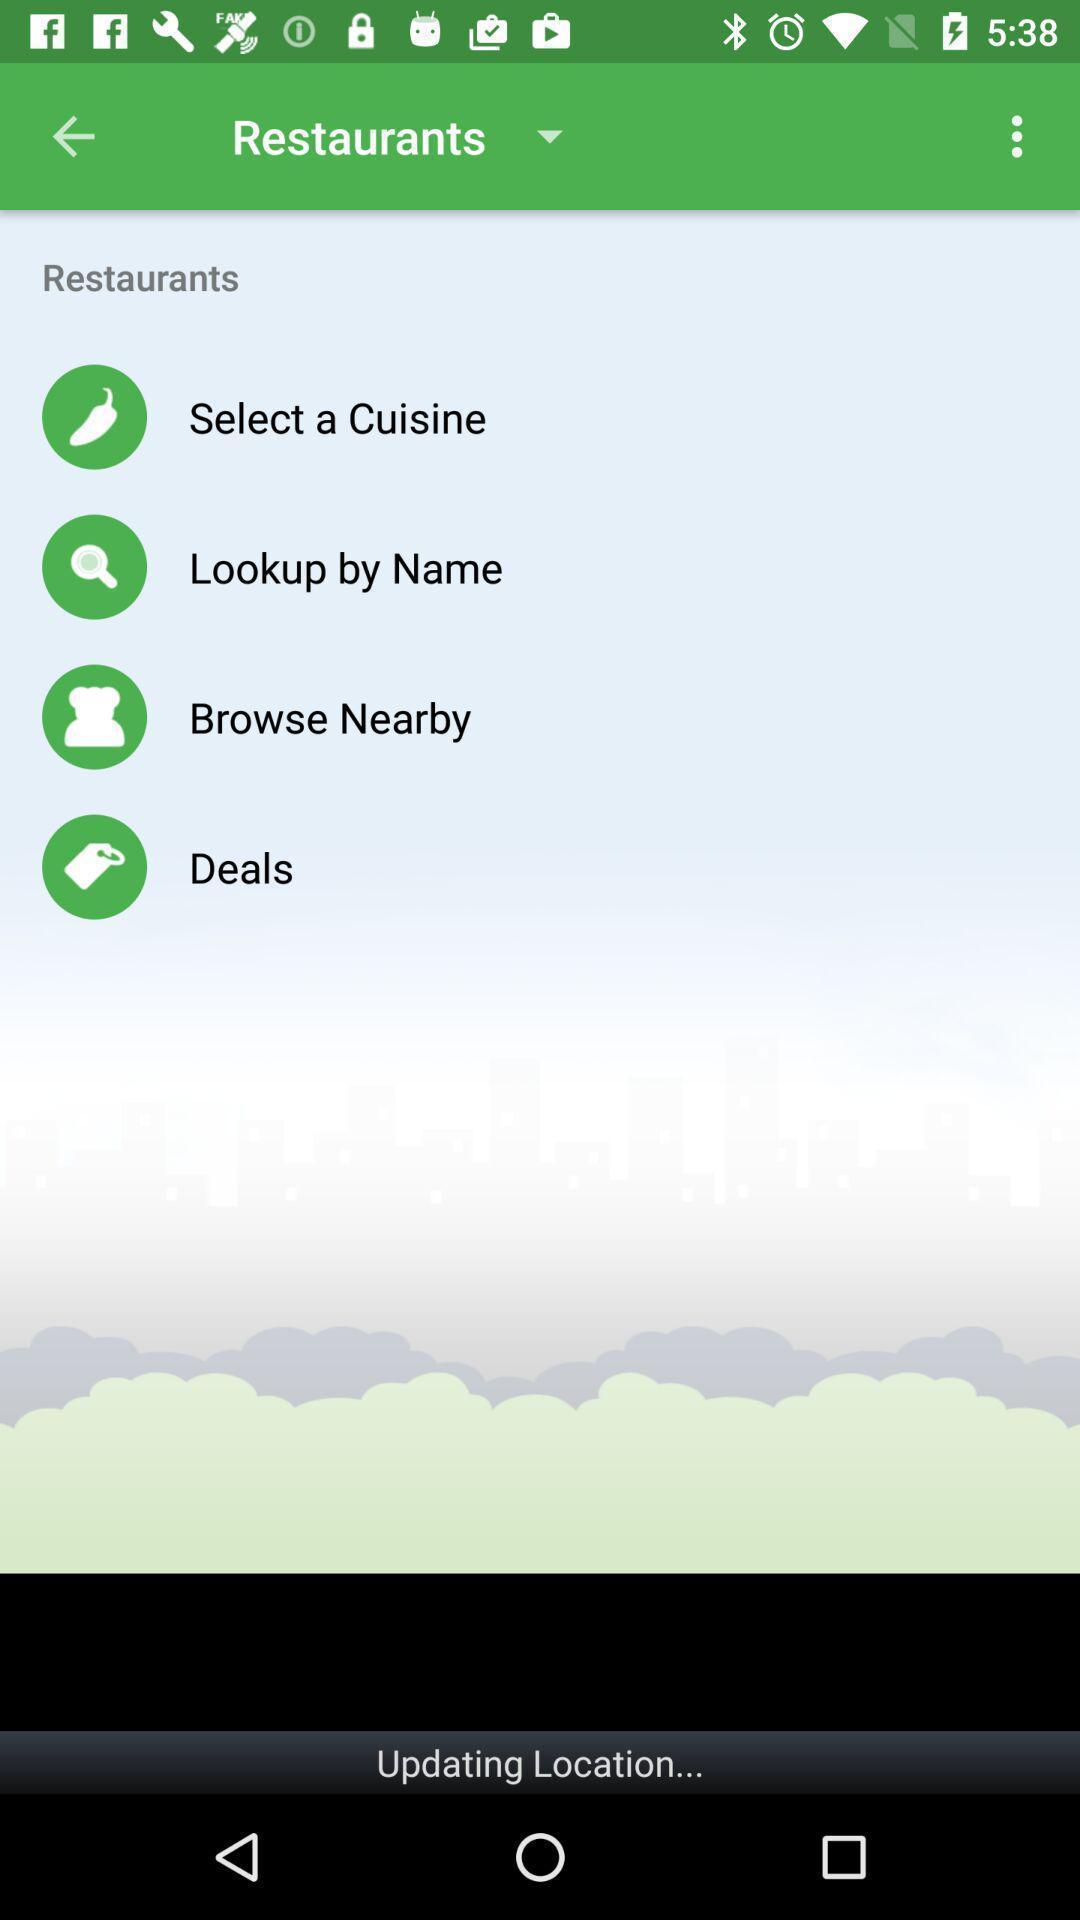What details can you identify in this image? Page showing different options in restaurants. 